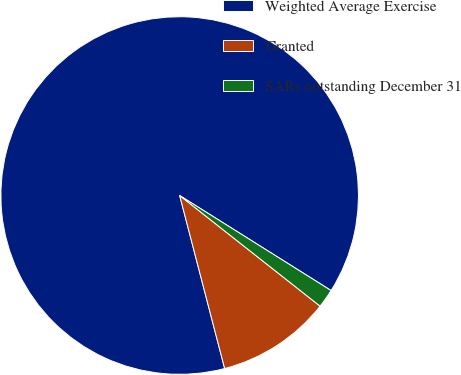Convert chart. <chart><loc_0><loc_0><loc_500><loc_500><pie_chart><fcel>Weighted Average Exercise<fcel>Granted<fcel>SARs outstanding December 31<nl><fcel>87.97%<fcel>10.33%<fcel>1.7%<nl></chart> 